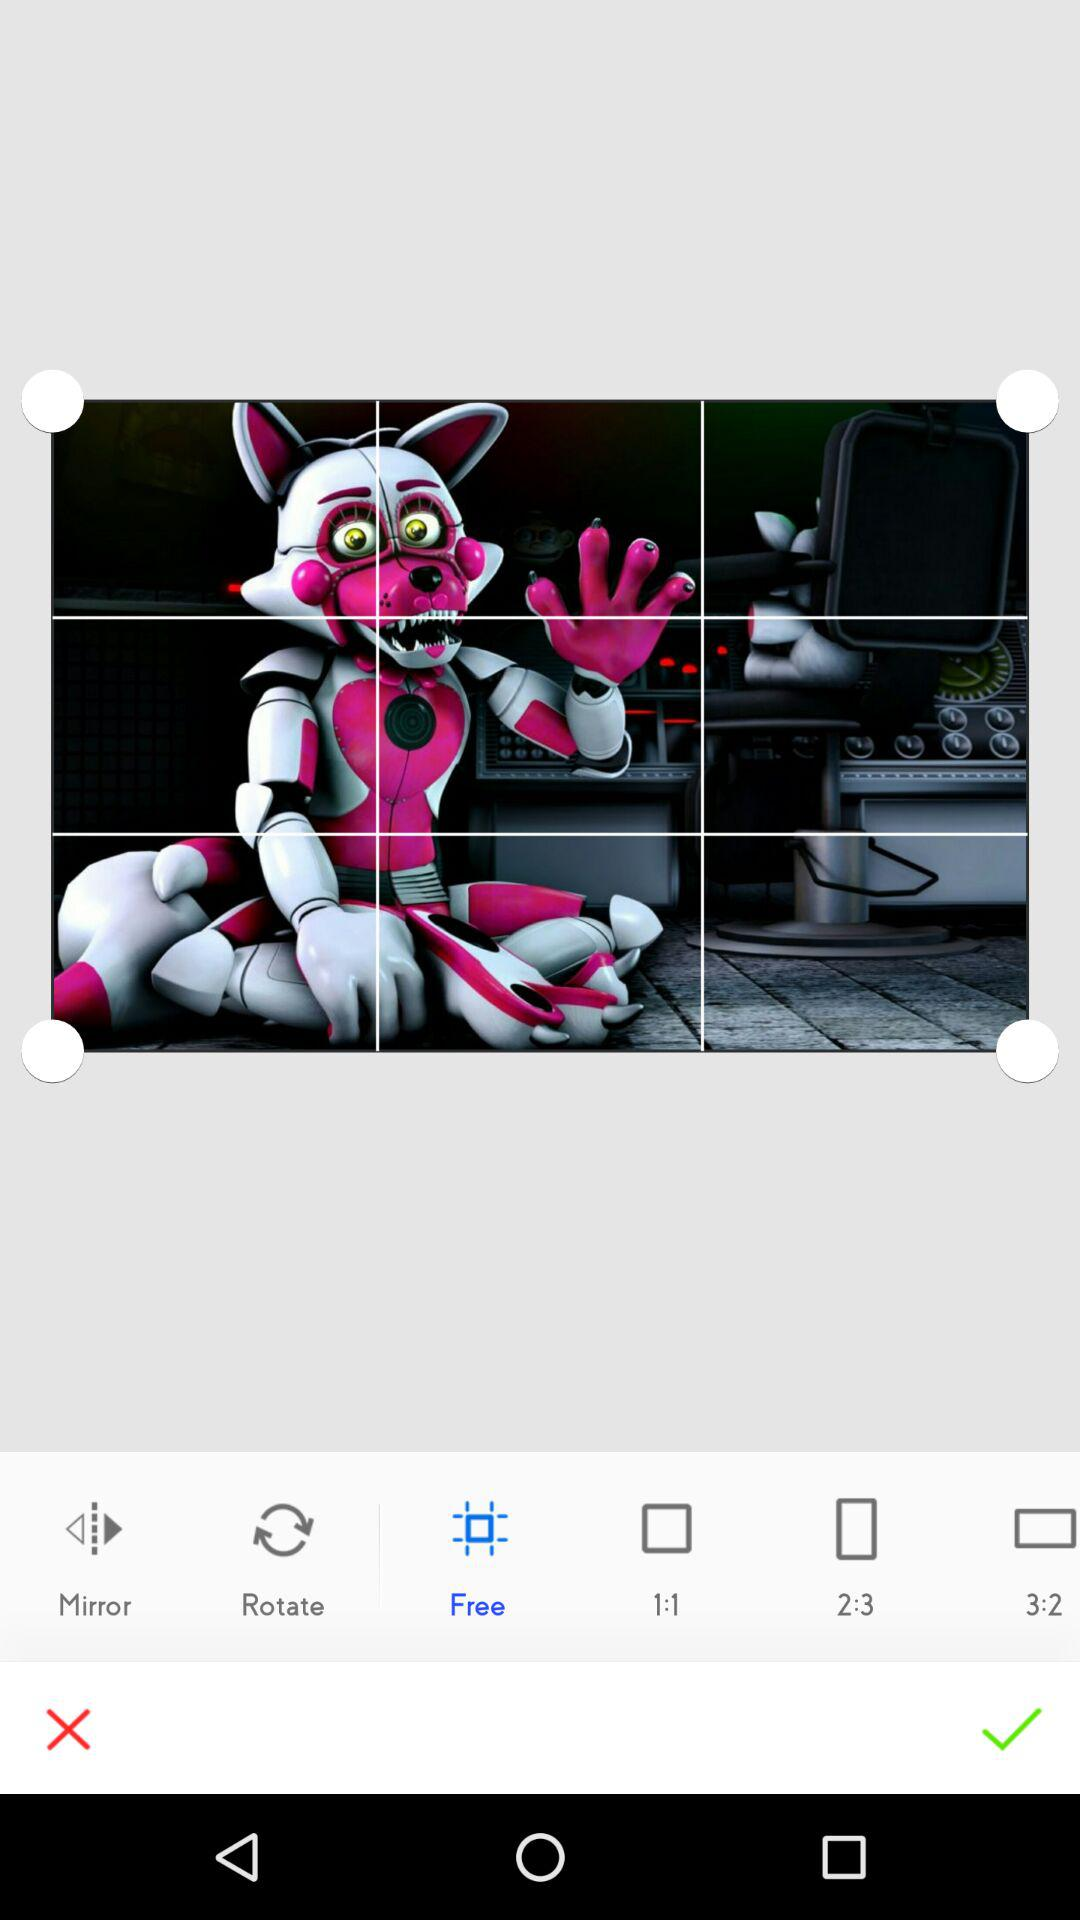Which tab has been selected? The selected tab is "Free". 